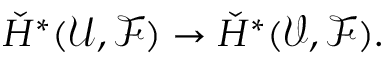<formula> <loc_0><loc_0><loc_500><loc_500>{ \check { H } } ^ { * } ( { \mathcal { U } } , { \mathcal { F } } ) \to { \check { H } } ^ { * } ( { \mathcal { V } } , { \mathcal { F } } ) .</formula> 